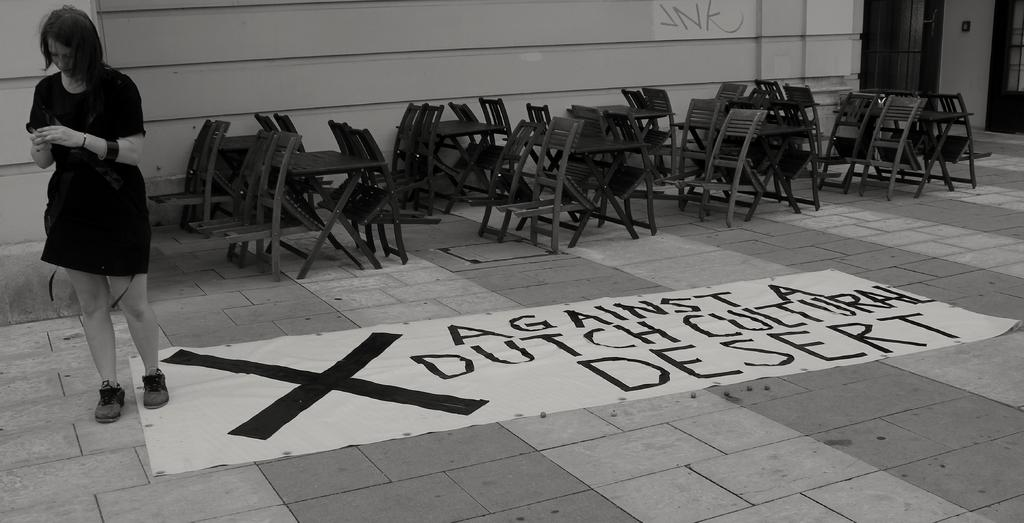Who is present in the image? There is a woman in the image. What type of furniture can be seen in the image? Chairs and tables are visible in the image. Where is the woman located in the image? The woman is on a path in the image. What can be seen in the background of the image? There is a wall in the background of the image. What type of brick is the woman using to attack the wall in the image? There is no brick or attack present in the image; the woman is simply on a path with a wall in the background. 